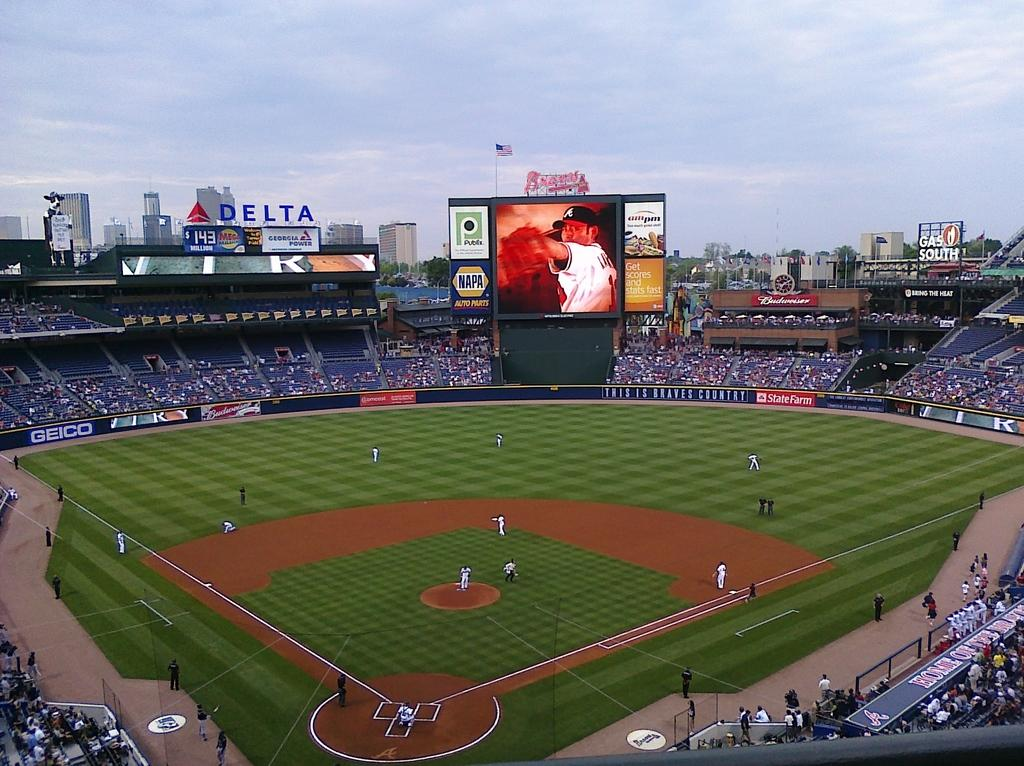Provide a one-sentence caption for the provided image. A jumbtron screen with a Napa ad on it. 